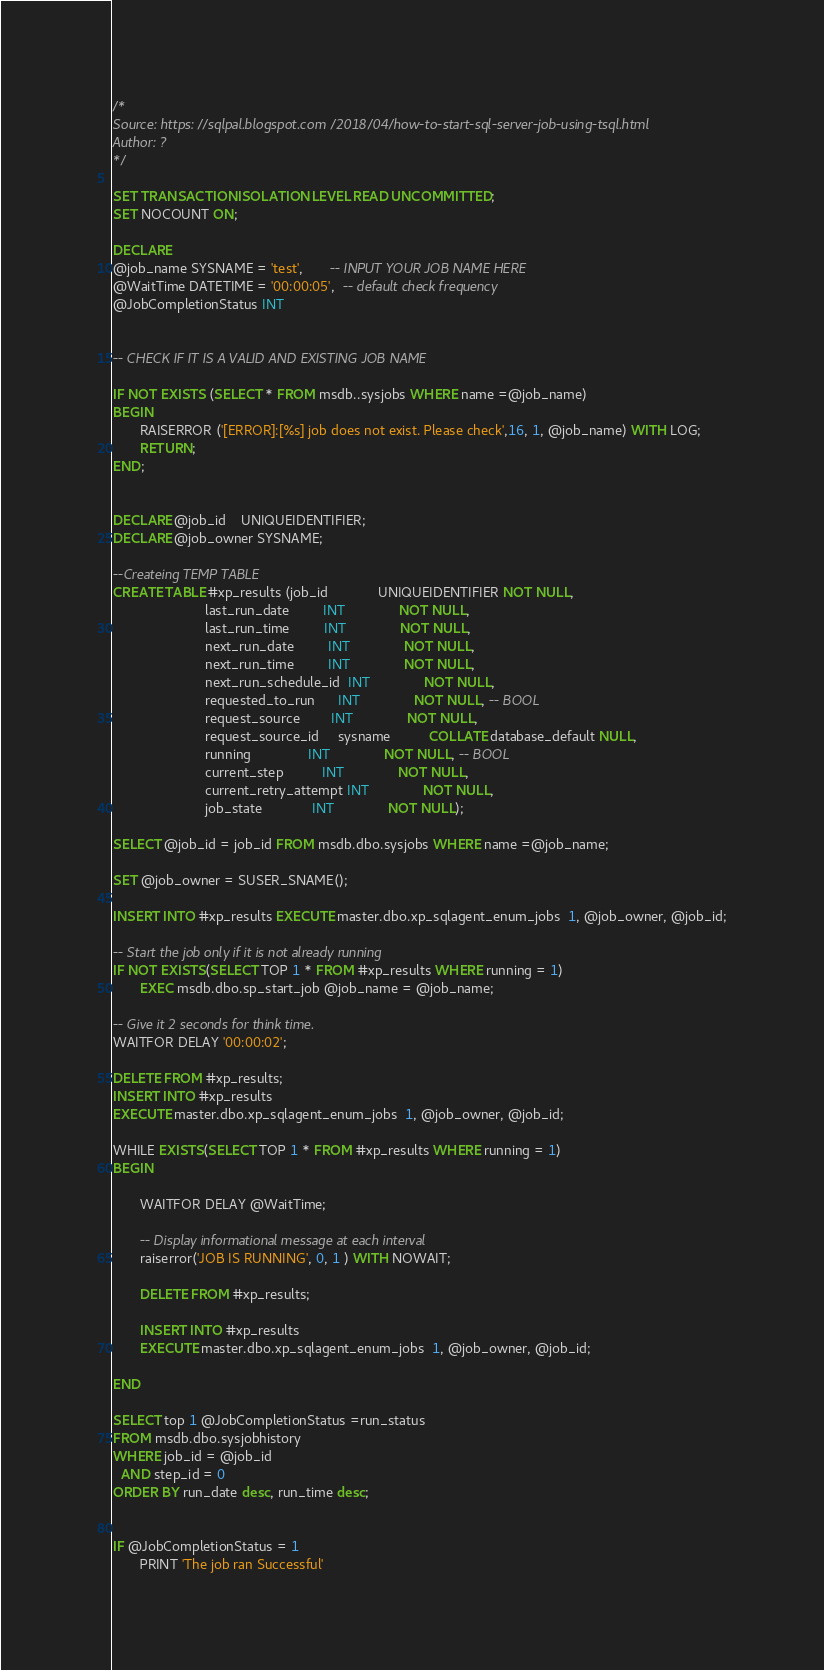<code> <loc_0><loc_0><loc_500><loc_500><_SQL_>/*
Source: https://sqlpal.blogspot.com/2018/04/how-to-start-sql-server-job-using-tsql.html
Author: ?
*/

SET TRANSACTION ISOLATION LEVEL READ UNCOMMITTED;
SET NOCOUNT ON;

DECLARE
@job_name SYSNAME = 'test',       -- INPUT YOUR JOB NAME HERE
@WaitTime DATETIME = '00:00:05',  -- default check frequency
@JobCompletionStatus INT


-- CHECK IF IT IS A VALID AND EXISTING JOB NAME

IF NOT EXISTS (SELECT * FROM msdb..sysjobs WHERE name =@job_name)
BEGIN
       RAISERROR ('[ERROR]:[%s] job does not exist. Please check',16, 1, @job_name) WITH LOG;
       RETURN;
END;


DECLARE @job_id    UNIQUEIDENTIFIER;
DECLARE @job_owner SYSNAME;

--Createing TEMP TABLE
CREATE TABLE #xp_results (job_id             UNIQUEIDENTIFIER NOT NULL,
                        last_run_date         INT              NOT NULL,
                        last_run_time         INT              NOT NULL,
                        next_run_date         INT              NOT NULL,
                        next_run_time         INT              NOT NULL,
                        next_run_schedule_id  INT              NOT NULL,
                        requested_to_run      INT              NOT NULL, -- BOOL
                        request_source        INT              NOT NULL,
                        request_source_id     sysname          COLLATE database_default NULL,
                        running               INT              NOT NULL, -- BOOL
                        current_step          INT              NOT NULL,
                        current_retry_attempt INT              NOT NULL,
                        job_state             INT              NOT NULL);

SELECT @job_id = job_id FROM msdb.dbo.sysjobs WHERE name =@job_name;

SET @job_owner = SUSER_SNAME();

INSERT INTO #xp_results EXECUTE master.dbo.xp_sqlagent_enum_jobs  1, @job_owner, @job_id;

-- Start the job only if it is not already running
IF NOT EXISTS(SELECT TOP 1 * FROM #xp_results WHERE running = 1)
       EXEC msdb.dbo.sp_start_job @job_name = @job_name;

-- Give it 2 seconds for think time.
WAITFOR DELAY '00:00:02';

DELETE FROM #xp_results;
INSERT INTO #xp_results
EXECUTE master.dbo.xp_sqlagent_enum_jobs  1, @job_owner, @job_id;

WHILE EXISTS(SELECT TOP 1 * FROM #xp_results WHERE running = 1)
BEGIN

       WAITFOR DELAY @WaitTime;

       -- Display informational message at each interval
       raiserror('JOB IS RUNNING', 0, 1 ) WITH NOWAIT;

       DELETE FROM #xp_results;

       INSERT INTO #xp_results
       EXECUTE master.dbo.xp_sqlagent_enum_jobs  1, @job_owner, @job_id;

END

SELECT top 1 @JobCompletionStatus =run_status
FROM msdb.dbo.sysjobhistory
WHERE job_id = @job_id
  AND step_id = 0
ORDER BY run_date desc, run_time desc;


IF @JobCompletionStatus = 1
       PRINT 'The job ran Successful'</code> 